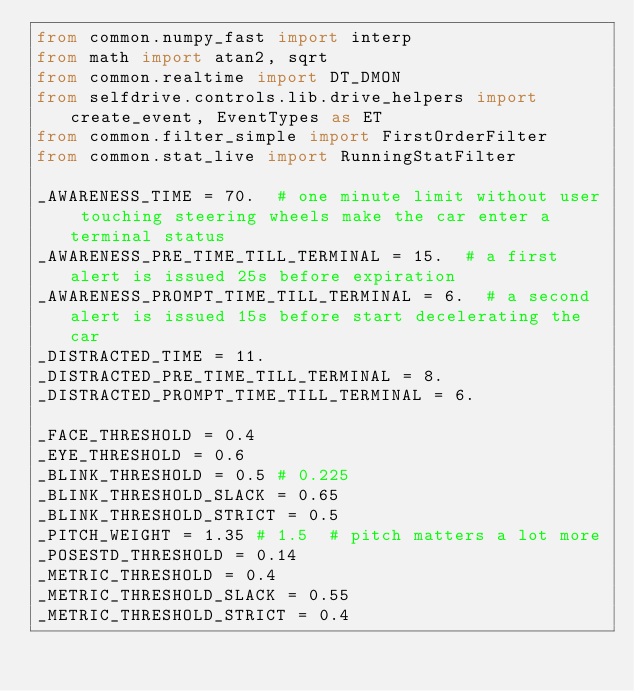<code> <loc_0><loc_0><loc_500><loc_500><_Python_>from common.numpy_fast import interp
from math import atan2, sqrt
from common.realtime import DT_DMON
from selfdrive.controls.lib.drive_helpers import create_event, EventTypes as ET
from common.filter_simple import FirstOrderFilter
from common.stat_live import RunningStatFilter

_AWARENESS_TIME = 70.  # one minute limit without user touching steering wheels make the car enter a terminal status
_AWARENESS_PRE_TIME_TILL_TERMINAL = 15.  # a first alert is issued 25s before expiration
_AWARENESS_PROMPT_TIME_TILL_TERMINAL = 6.  # a second alert is issued 15s before start decelerating the car
_DISTRACTED_TIME = 11.
_DISTRACTED_PRE_TIME_TILL_TERMINAL = 8.
_DISTRACTED_PROMPT_TIME_TILL_TERMINAL = 6.

_FACE_THRESHOLD = 0.4
_EYE_THRESHOLD = 0.6
_BLINK_THRESHOLD = 0.5 # 0.225
_BLINK_THRESHOLD_SLACK = 0.65
_BLINK_THRESHOLD_STRICT = 0.5
_PITCH_WEIGHT = 1.35 # 1.5  # pitch matters a lot more
_POSESTD_THRESHOLD = 0.14
_METRIC_THRESHOLD = 0.4
_METRIC_THRESHOLD_SLACK = 0.55
_METRIC_THRESHOLD_STRICT = 0.4</code> 